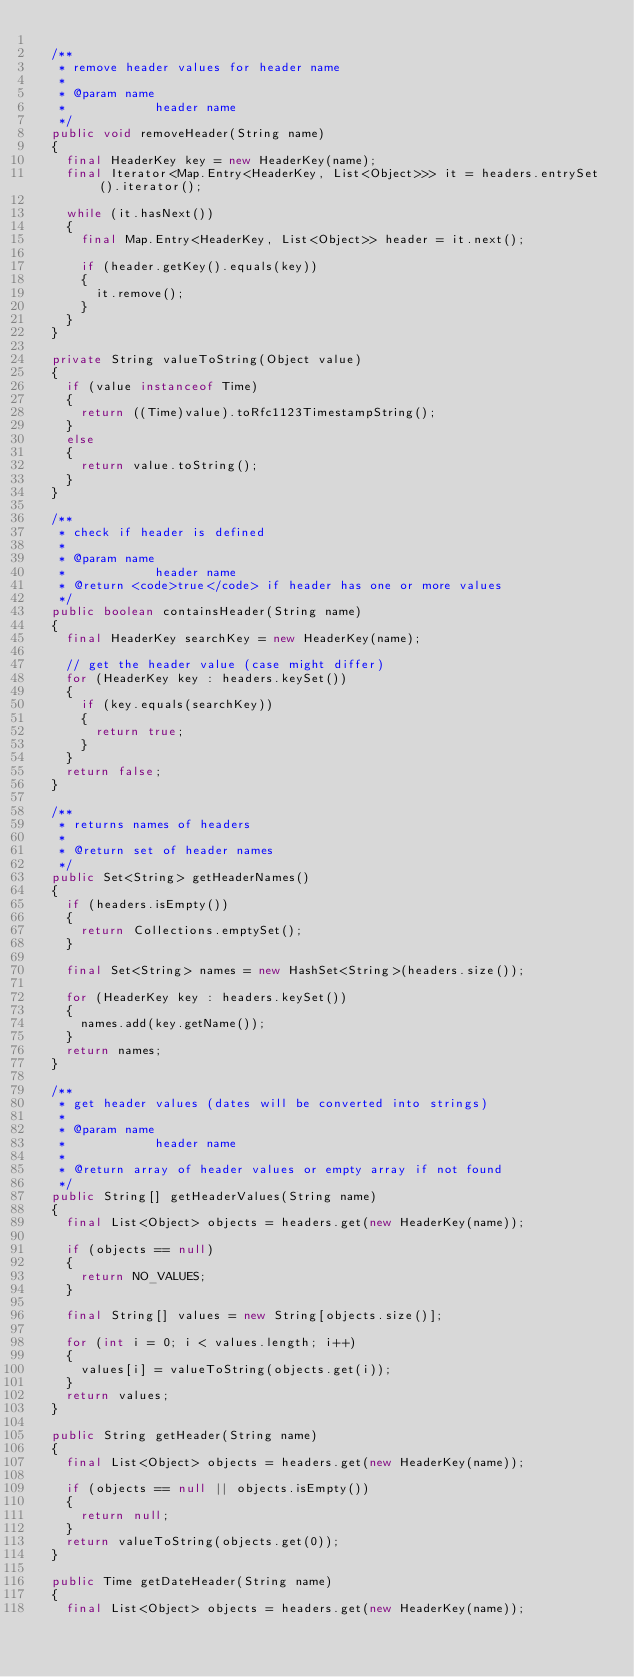Convert code to text. <code><loc_0><loc_0><loc_500><loc_500><_Java_>
	/**
	 * remove header values for header name
	 * 
	 * @param name
	 *            header name
	 */
	public void removeHeader(String name)
	{
		final HeaderKey key = new HeaderKey(name);
		final Iterator<Map.Entry<HeaderKey, List<Object>>> it = headers.entrySet().iterator();

		while (it.hasNext())
		{
			final Map.Entry<HeaderKey, List<Object>> header = it.next();

			if (header.getKey().equals(key))
			{
				it.remove();
			}
		}
	}

	private String valueToString(Object value)
	{
		if (value instanceof Time)
		{
			return ((Time)value).toRfc1123TimestampString();
		}
		else
		{
			return value.toString();
		}
	}

	/**
	 * check if header is defined
	 * 
	 * @param name
	 *            header name
	 * @return <code>true</code> if header has one or more values
	 */
	public boolean containsHeader(String name)
	{
		final HeaderKey searchKey = new HeaderKey(name);

		// get the header value (case might differ)
		for (HeaderKey key : headers.keySet())
		{
			if (key.equals(searchKey))
			{
				return true;
			}
		}
		return false;
	}

	/**
	 * returns names of headers
	 * 
	 * @return set of header names
	 */
	public Set<String> getHeaderNames()
	{
		if (headers.isEmpty())
		{
			return Collections.emptySet();
		}

		final Set<String> names = new HashSet<String>(headers.size());

		for (HeaderKey key : headers.keySet())
		{
			names.add(key.getName());
		}
		return names;
	}

	/**
	 * get header values (dates will be converted into strings)
	 * 
	 * @param name
	 *            header name
	 * 
	 * @return array of header values or empty array if not found
	 */
	public String[] getHeaderValues(String name)
	{
		final List<Object> objects = headers.get(new HeaderKey(name));

		if (objects == null)
		{
			return NO_VALUES;
		}

		final String[] values = new String[objects.size()];

		for (int i = 0; i < values.length; i++)
		{
			values[i] = valueToString(objects.get(i));
		}
		return values;
	}

	public String getHeader(String name)
	{
		final List<Object> objects = headers.get(new HeaderKey(name));

		if (objects == null || objects.isEmpty())
		{
			return null;
		}
		return valueToString(objects.get(0));
	}

	public Time getDateHeader(String name)
	{
		final List<Object> objects = headers.get(new HeaderKey(name));
</code> 